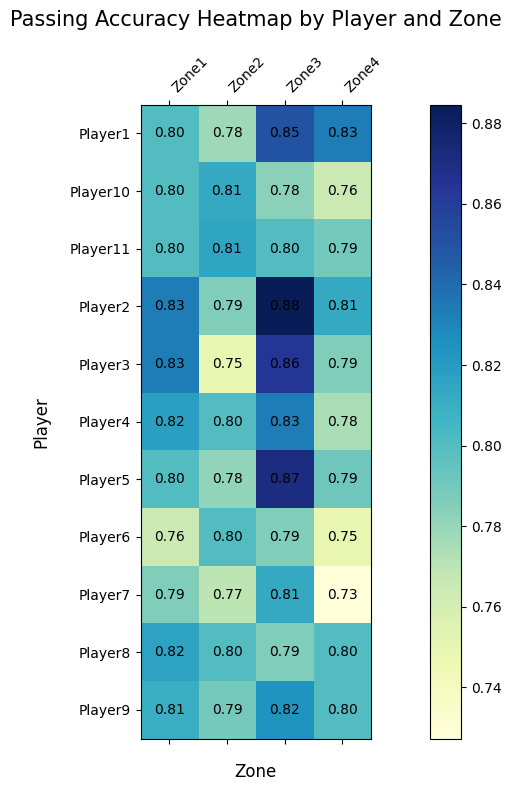Which player has the highest passing accuracy in Zone 1? By visually inspecting the heatmap, note the color intensity for Zone 1 across all players. The darkest shade represents the highest passing accuracy. Read the labeled accuracy value for the player associated with the darkest shade in Zone 1.
Answer: Player5 Which zone has the lowest passing accuracy for Player6? Compare the shades of color across all four zones for Player6. The lightest shade indicates the lowest passing accuracy. Look at the specific accuracy values to confirm.
Answer: Zone1 Who has the highest average passing accuracy across all zones? Calculate the average passing accuracy for each player by summing up their accuracies across all zones and then dividing by the number of zones. Compare these averages to determine the highest one.
Answer: Player5 How does the passing accuracy of Player8 in Zone2 compare to Player2 in Zone3? Look at the heatmap values for Player8 in Zone2 and Player2 in Zone3. Compare these values numerically to determine which is higher or if they are equal.
Answer: Higher for Player2 in Zone3 Which player shows the most consistent passing accuracy across all zones? Assess the variation in passing accuracy for each player by noting the range (difference between highest and lowest values) of accuracies in all zones. The player with the smallest range exhibits the most consistency.
Answer: Player1 What is the combined passing accuracy of Player3 in Zone2 and Zone4? Add the passing accuracy values of Player3 in Zone2 and Zone4. Look at the individual values and perform the addition.
Answer: 1.10 (0.75 + 0.35) Is there a noticeable difference in passing accuracy between Zone1 and Zone4 for the majority of players? Examine the colors in Zone1 and Zone4 for all players. Look for a pattern or notable difference in color shade between these two zones for most players. If Zone1 generally has a darker color compared to Zone4, it indicates higher accuracy in Zone1.
Answer: Yes Which zone has the best overall passing accuracy when averaging across all players? Calculate the average passing accuracy for each zone by summing up all players' accuracies in that zone and then dividing by the number of players. Compare these averages to identify the highest one.
Answer: Zone1 How does Player10's passing accuracy in Zone3 compare visually to that of Player7's in the same zone? Observe the color shades in Zone3 for both Player10 and Player7. A darker shade indicates a higher passing accuracy. By comparing the two shades, determine which player has better accuracy in that zone.
Answer: Higher for Player10 Which zone shows the greatest variation in passing accuracy among players? Measure the difference between the highest and lowest passing accuracy values for each zone among all players. The zone with the largest range indicates the greatest variation.
Answer: Zone4 